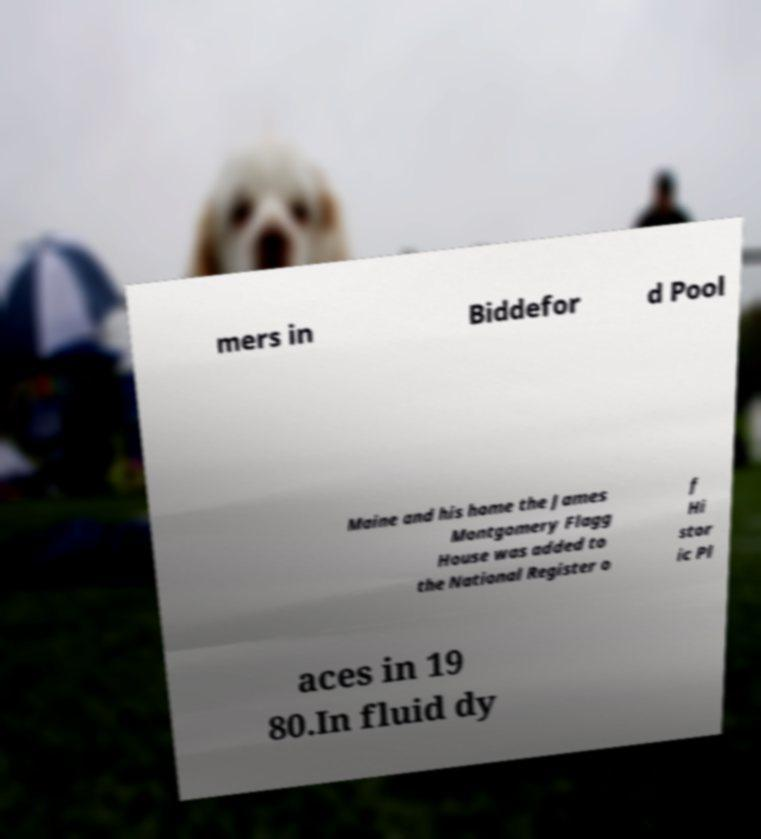Could you assist in decoding the text presented in this image and type it out clearly? mers in Biddefor d Pool Maine and his home the James Montgomery Flagg House was added to the National Register o f Hi stor ic Pl aces in 19 80.In fluid dy 